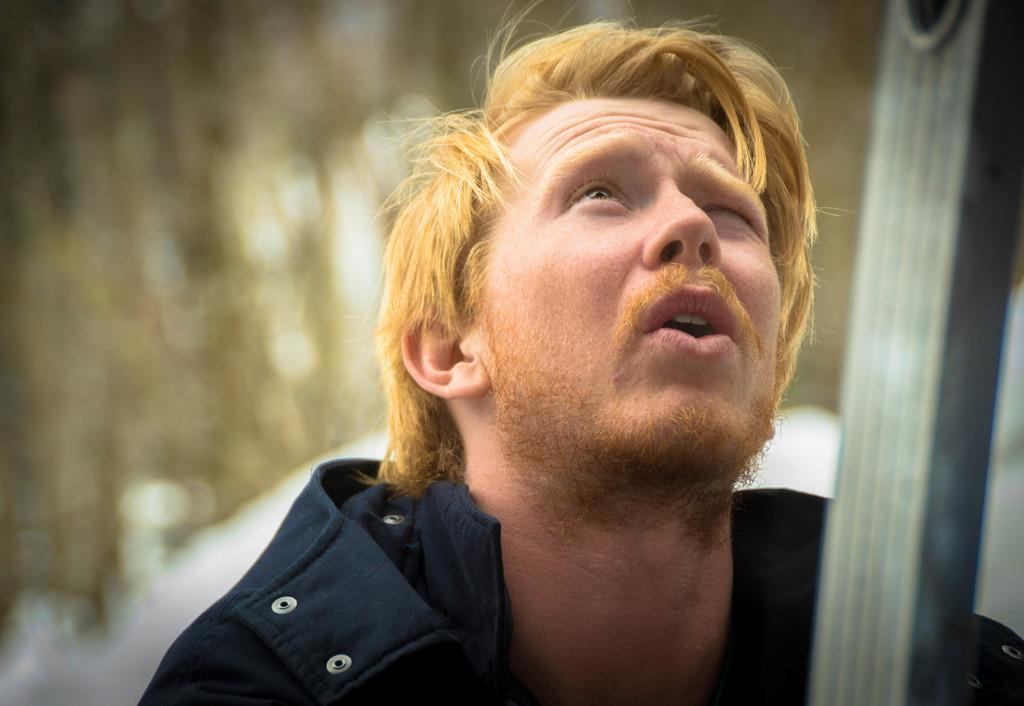What is present in the image? There is a man and an object in the image. Can you describe the man in the image? Unfortunately, the provided facts do not give any details about the man's appearance or actions. What can you tell me about the object in the image? Unfortunately, the provided facts do not give any details about the object. What is the man talking about with the goat in the image? There is no goat present in the image, so it is not possible to answer that question. 